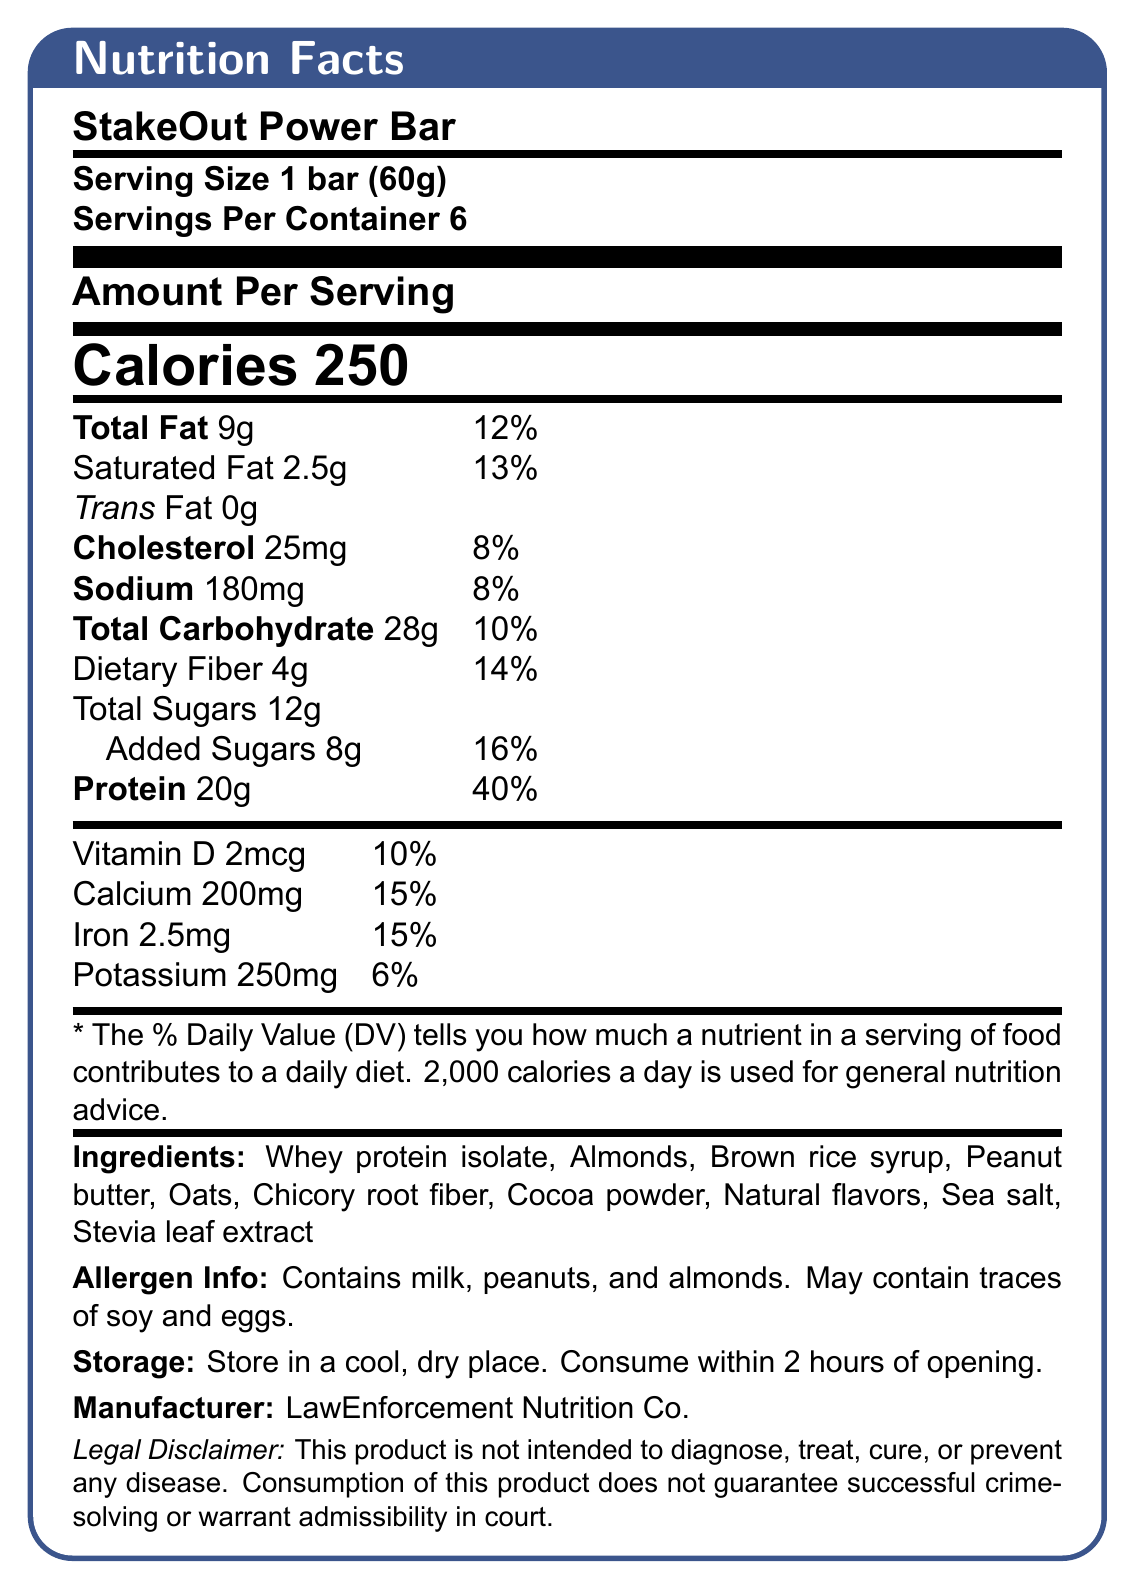what is the serving size for the StakeOut Power Bar? The serving size is explicitly stated as "1 bar (60g)" in the document.
Answer: 1 bar (60g) how many servings are in one container? The document mentions that there are 6 servings per container.
Answer: 6 how many grams of protein are in one serving? The amount of protein per serving is listed as 20g.
Answer: 20g what percentage of the daily value for iron does one serving contain? The document states that one serving contains 15% of the daily value for iron.
Answer: 15% which ingredient is listed first in the ingredients list? The first ingredient listed is Whey protein isolate.
Answer: Whey protein isolate how much dietary fiber is in one serving of the bar? The dietary fiber content per serving is listed as 4g.
Answer: 4g what is the calorie content per serving of the StakeOut Power Bar? The calorie content per serving is listed as 250 calories.
Answer: 250 calories how much saturated fat does the bar contain per serving? The amount of saturated fat per serving is listed as 2.5g.
Answer: 2.5g what is the sodium content per serving? A. 180mg B. 250mg C. 200mg D. 2.5mg The sodium content per serving is listed as 180mg.
Answer: A which of the following allergens are contained in the bar? I. Milk II. Soy III. Eggs IV. Peanuts The allergen info states that the bar contains milk and peanuts.
Answer: I and IV does the StakeOut Power Bar contain any trans fat? The document states that the trans fat content is 0g.
Answer: No what is the general recommendation regarding daily caloric intake mentioned in the small print? The small print states that 2,000 calories a day is used for general nutrition advice.
Answer: 2,000 calories a day can you determine the sugar source for the StakeOut Power Bar from the document? The document does not specify the source of the sugars (e.g., from which ingredients).
Answer: No summarize the general nutritional content and key information of the StakeOut Power Bar. The document includes comprehensive details on nutritional values, ingredients, allergens, storage instructions, and a legal disclaimer. Each component is crucial for understanding the product's benefits and potential risks, especially during long stakeouts.
Answer: The StakeOut Power Bar provides detailed information about its nutritional content, ingredients, and allergen information. Each 60g bar contains 250 calories, 20g of protein, and 28g of total carbohydrates including 12g of sugars. It is primarily made from whey protein isolate, almonds, brown rice syrup, and other natural ingredients. It contains allergens such as milk, peanuts, and almonds and advises storing in a cool, dry place. what is the name of the company that manufactures the StakeOut Power Bar? The manufacturer is listed as LawEnforcement Nutrition Co. in the document.
Answer: LawEnforcement Nutrition Co. 